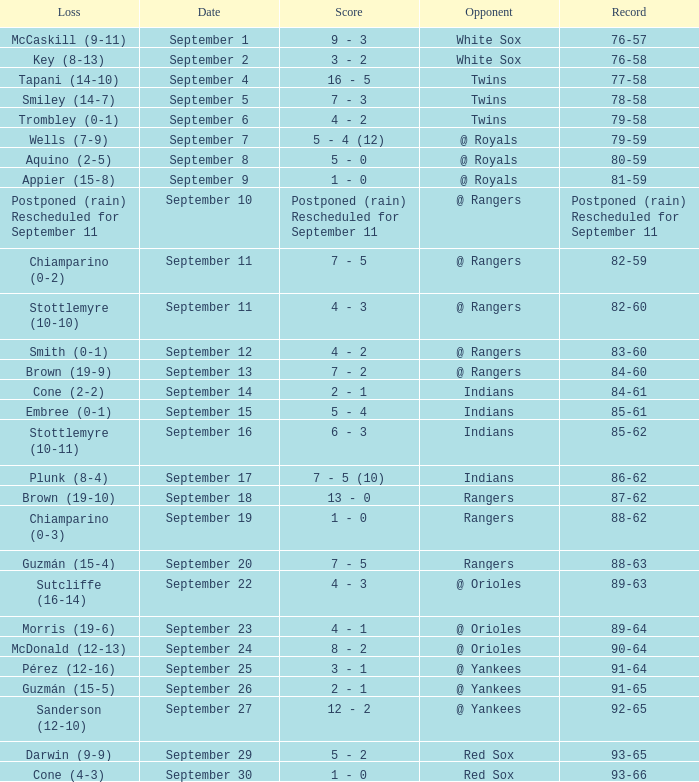What's the loss for September 16? Stottlemyre (10-11). 